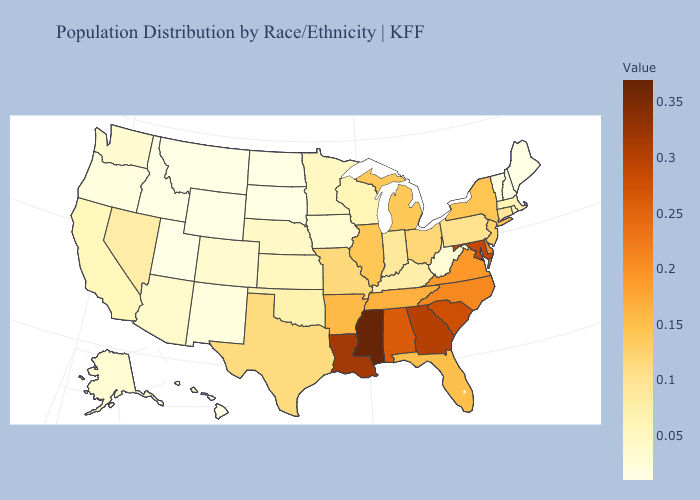Does Utah have the lowest value in the USA?
Concise answer only. Yes. Does Mississippi have a lower value than Texas?
Short answer required. No. Which states have the lowest value in the Northeast?
Short answer required. Maine, New Hampshire. Is the legend a continuous bar?
Keep it brief. Yes. Among the states that border Nebraska , does Wyoming have the lowest value?
Concise answer only. Yes. Among the states that border Arizona , which have the lowest value?
Write a very short answer. Utah. Which states have the lowest value in the West?
Answer briefly. Idaho, Montana, Utah, Wyoming. Does Wyoming have the lowest value in the USA?
Keep it brief. Yes. 